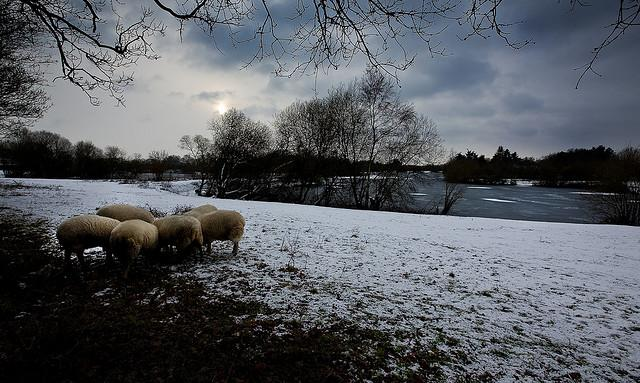These animals are in a formation that is reminiscent of what sport?

Choices:
A) ping pong
B) tennis
C) archery
D) football football 